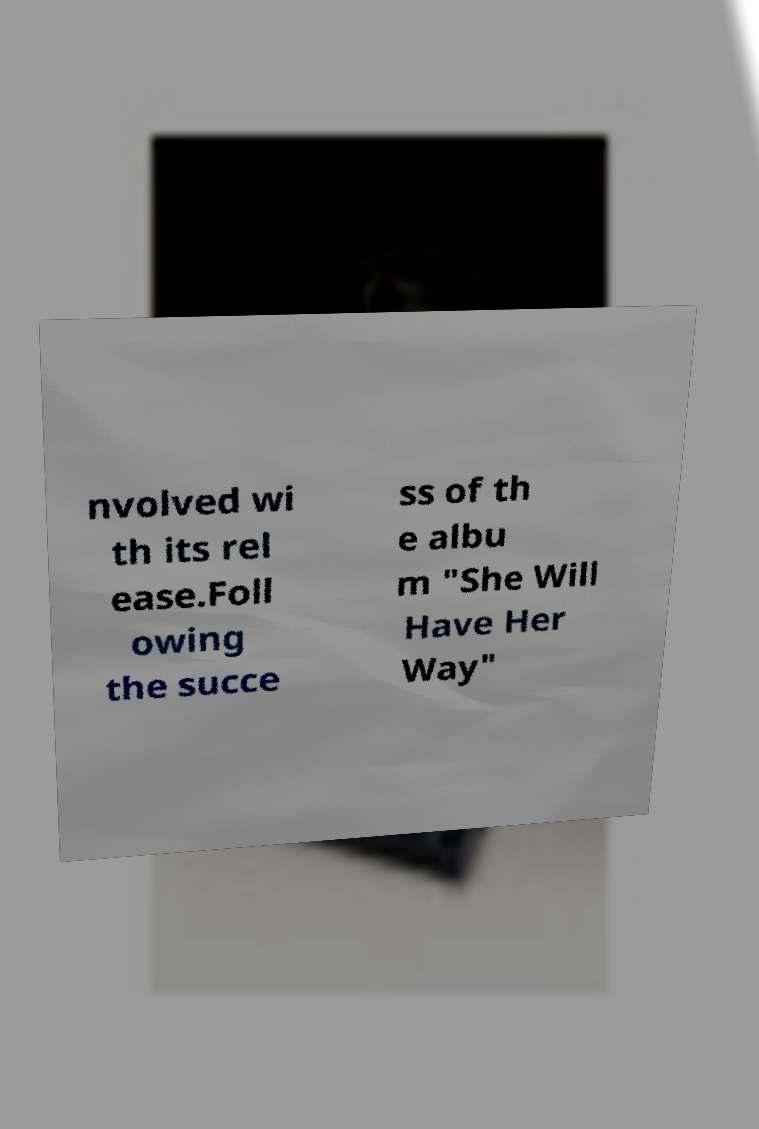Can you accurately transcribe the text from the provided image for me? nvolved wi th its rel ease.Foll owing the succe ss of th e albu m "She Will Have Her Way" 